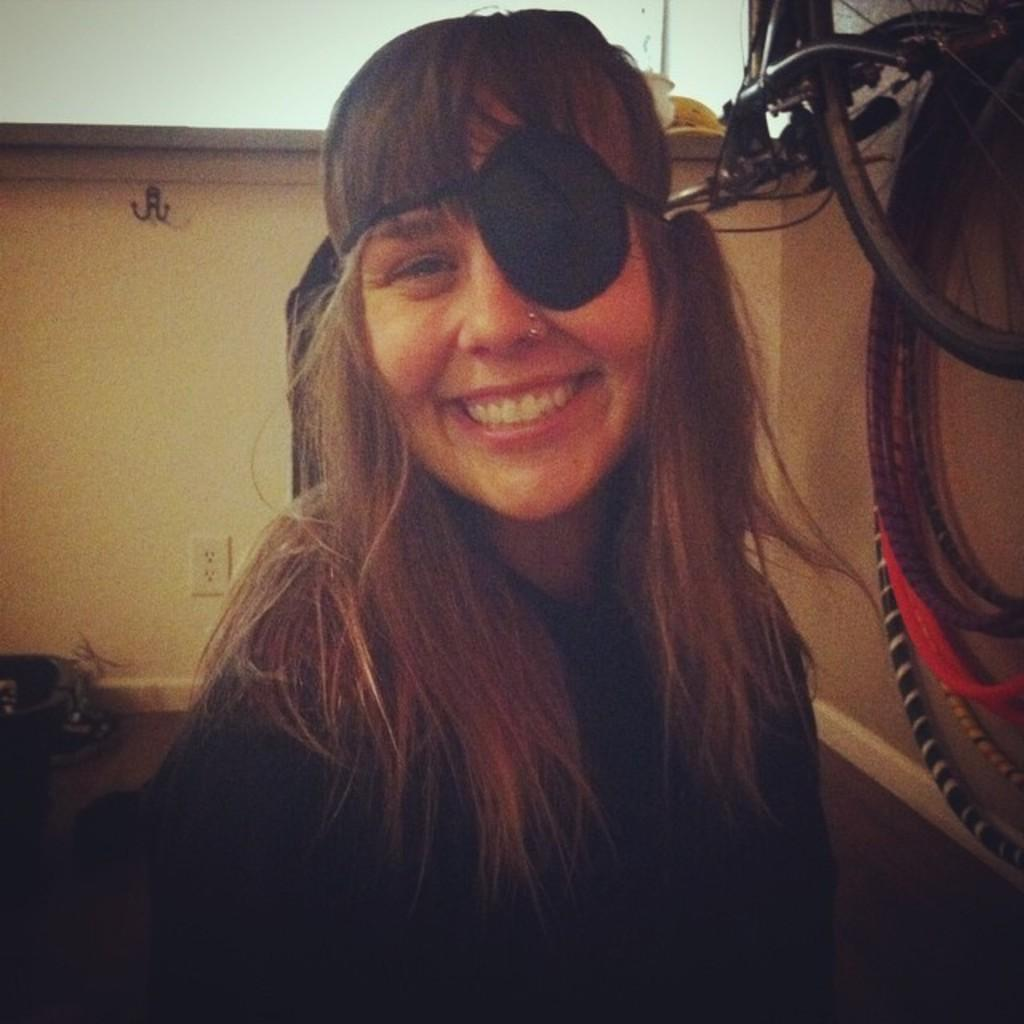Who is present in the image? There is a woman in the image. What is the woman doing in the image? The woman is smiling and giving a pose for the picture. What can be seen on the right side of the image? There is a bicycle on the right side of the image. What is visible in the background of the image? There is a wall in the background of the image. What discovery was made on the shelf in the image? There is no shelf present in the image, and therefore no discovery can be made. 